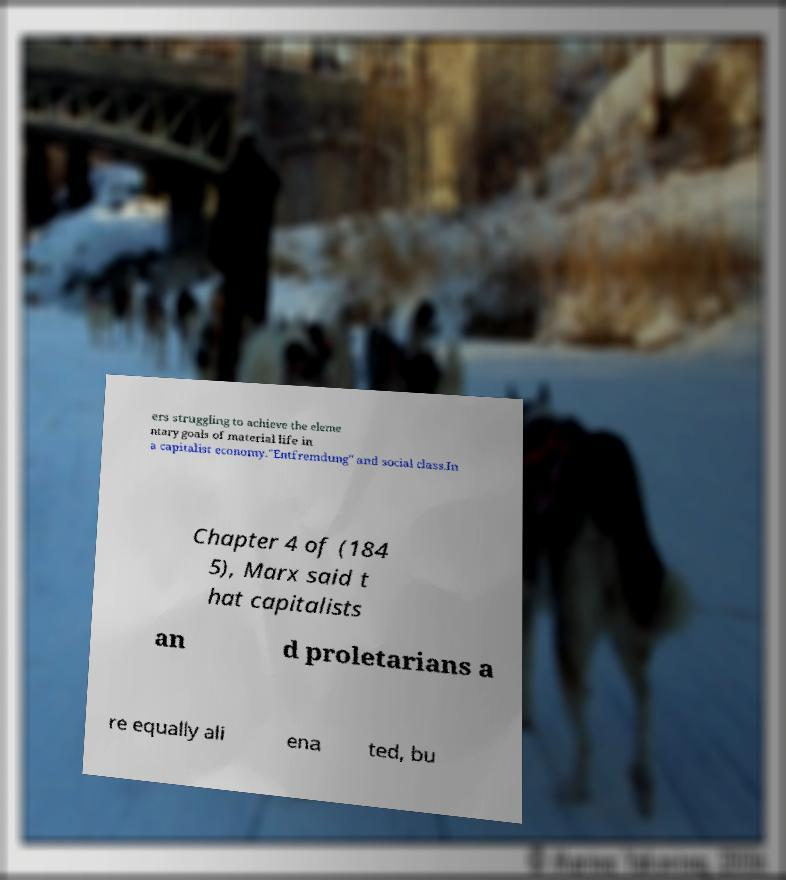For documentation purposes, I need the text within this image transcribed. Could you provide that? ers struggling to achieve the eleme ntary goals of material life in a capitalist economy."Entfremdung" and social class.In Chapter 4 of (184 5), Marx said t hat capitalists an d proletarians a re equally ali ena ted, bu 